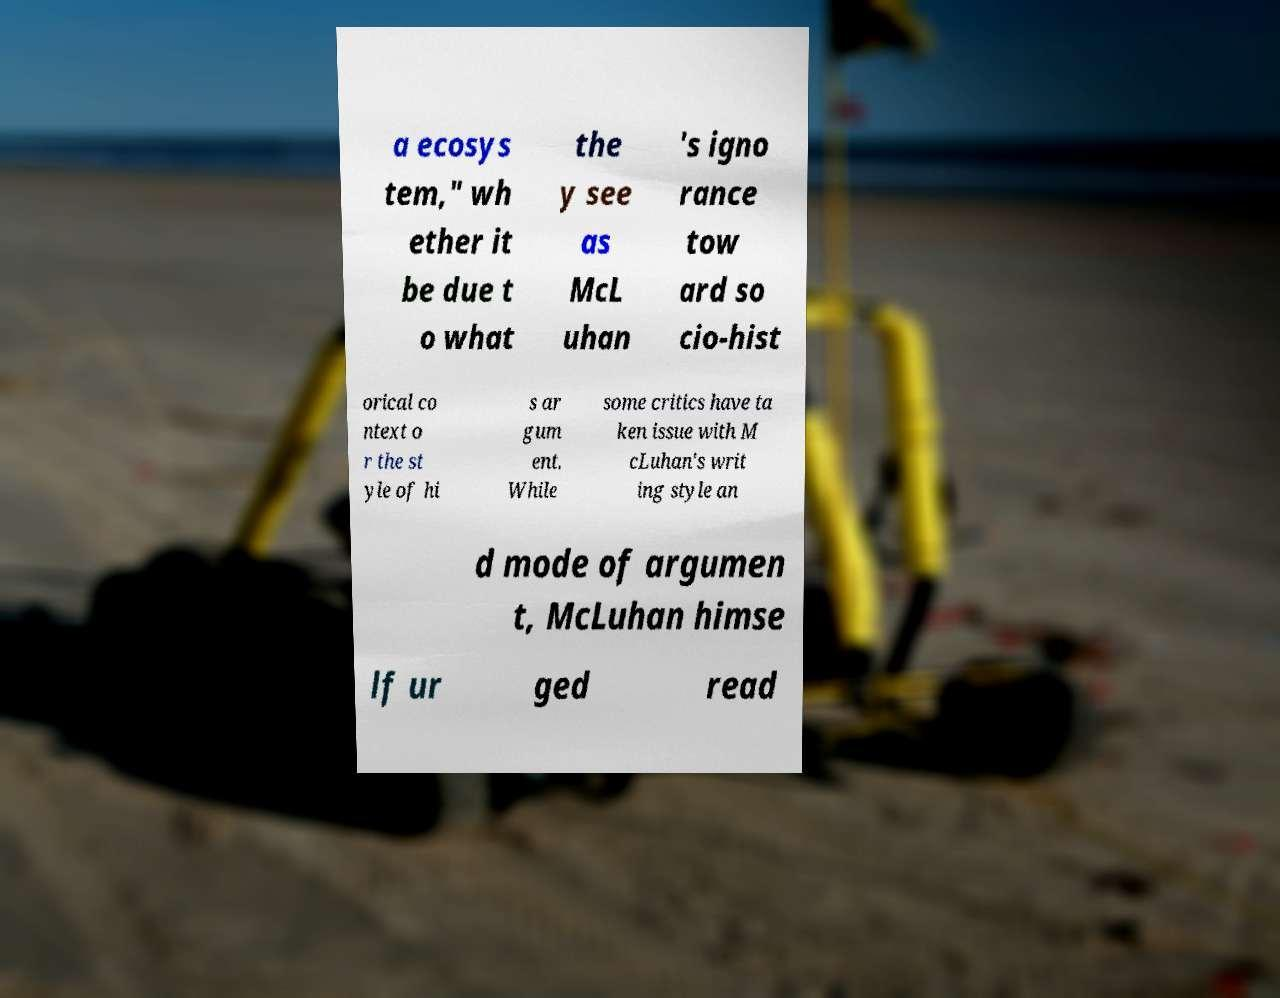I need the written content from this picture converted into text. Can you do that? a ecosys tem," wh ether it be due t o what the y see as McL uhan 's igno rance tow ard so cio-hist orical co ntext o r the st yle of hi s ar gum ent. While some critics have ta ken issue with M cLuhan's writ ing style an d mode of argumen t, McLuhan himse lf ur ged read 